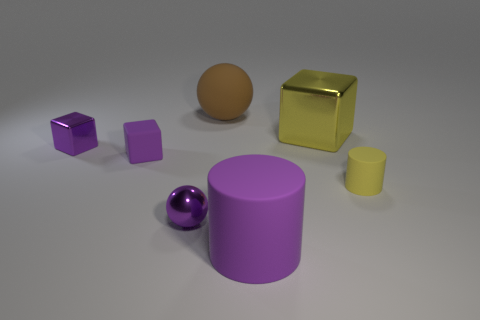Does the small rubber cylinder have the same color as the shiny ball?
Provide a short and direct response. No. Is the size of the purple metal object on the left side of the tiny rubber cube the same as the yellow metallic object that is behind the tiny yellow rubber cylinder?
Give a very brief answer. No. The purple metallic object that is in front of the rubber cylinder that is behind the big purple thing is what shape?
Offer a terse response. Sphere. Are there an equal number of brown objects in front of the yellow metallic block and large purple matte objects?
Your response must be concise. No. What is the material of the large object that is right of the purple object that is to the right of the big brown rubber ball that is behind the large purple matte object?
Offer a very short reply. Metal. Is there a rubber thing of the same size as the purple metal cube?
Offer a very short reply. Yes. What is the shape of the large brown rubber thing?
Make the answer very short. Sphere. What number of cylinders are either tiny matte things or tiny purple matte things?
Offer a very short reply. 1. Is the number of tiny purple spheres that are in front of the small shiny ball the same as the number of tiny yellow rubber objects in front of the large matte cylinder?
Keep it short and to the point. Yes. How many large yellow things are behind the small purple metal thing that is behind the purple metallic sphere to the left of the yellow rubber thing?
Provide a short and direct response. 1. 